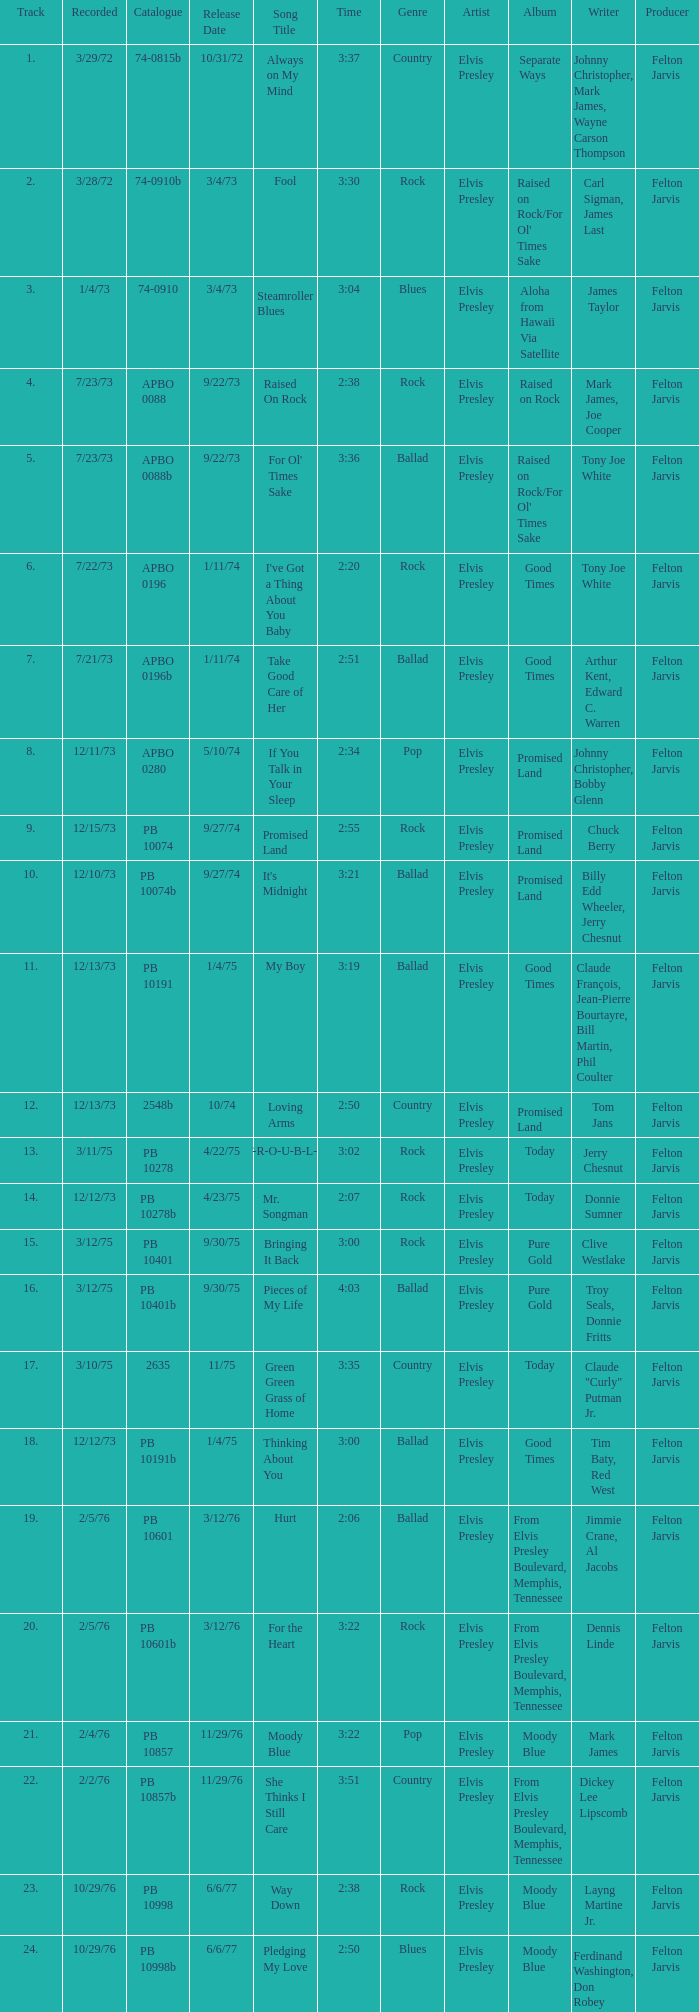Tell me the time for 6/6/77 release date and song title of way down 2:38. 